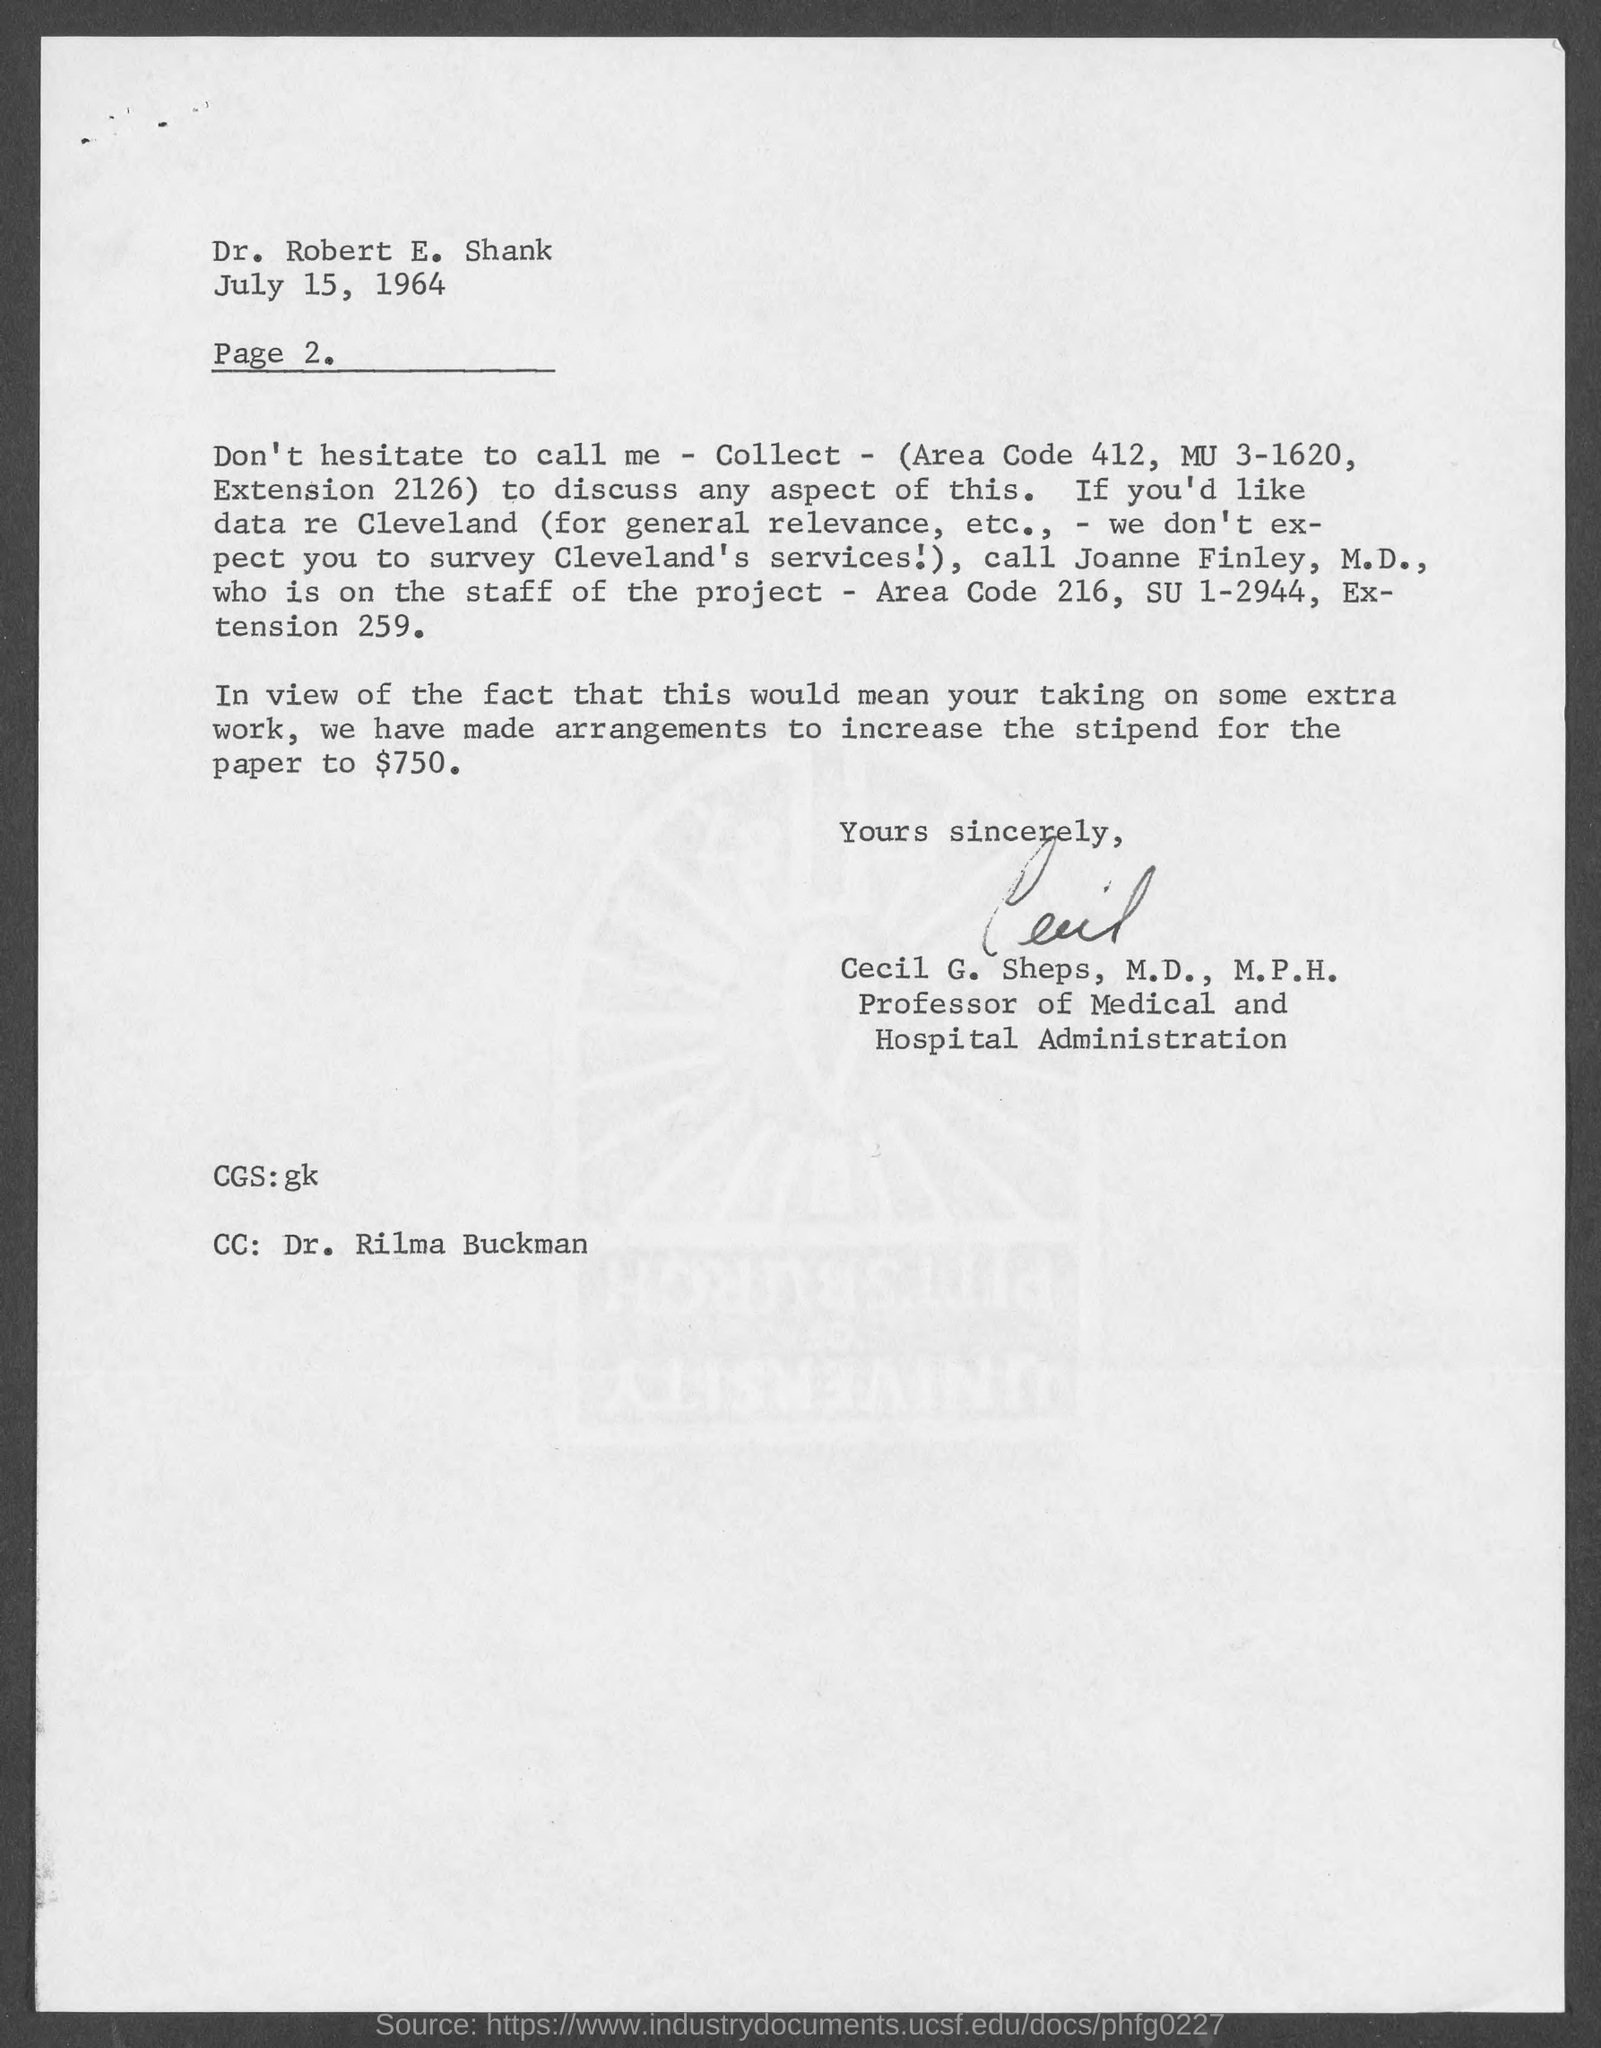On which date the letter is dated on?
Your response must be concise. July 15, 1964. To whom this letter is written to?
Ensure brevity in your answer.  Dr. Robert E. Shank. What is the page number mentioned below date?
Provide a succinct answer. 2. Who wrote this letter?
Offer a very short reply. Cecil G. Sheps, M.D., M.P.H. What amount is stipend for paper is arranged to increase to?
Make the answer very short. $750. Who is cc mentioned at bottom-left of the page?
Provide a succinct answer. Dr. Rilma Buckman. Who is the professor of medical and hospital administration?
Give a very brief answer. Cecil G. Sheps, M.D., M.P.H. 